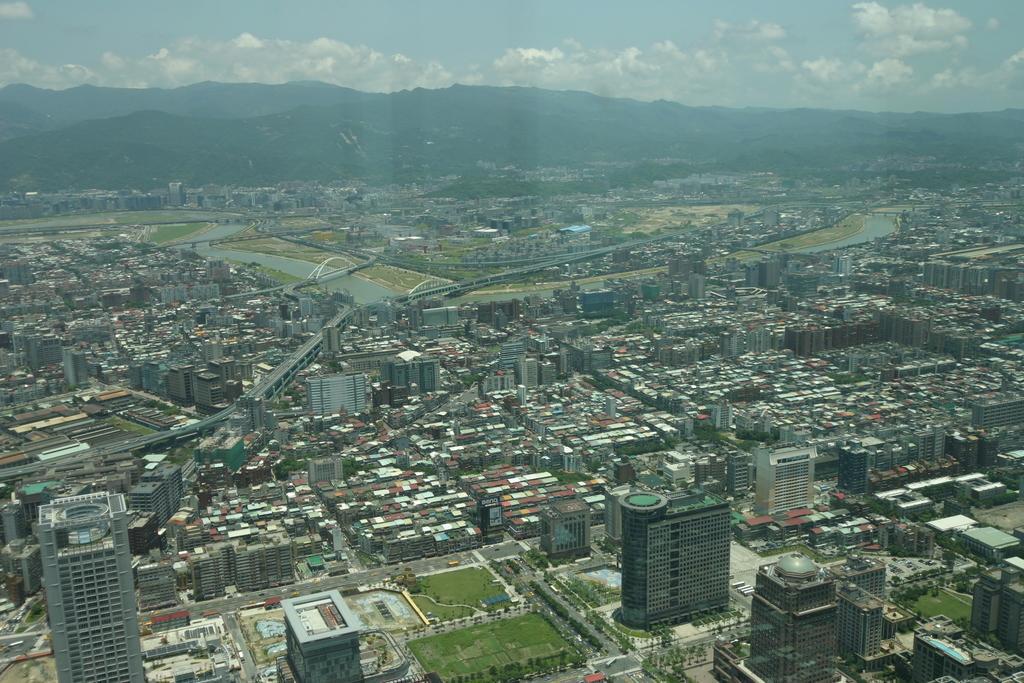Please provide a concise description of this image. In this picture we can see a glass in the front, from the glass we can see buildings, grass, trees, water, bridge and a train, there is the sky and clouds at the top of the picture. 